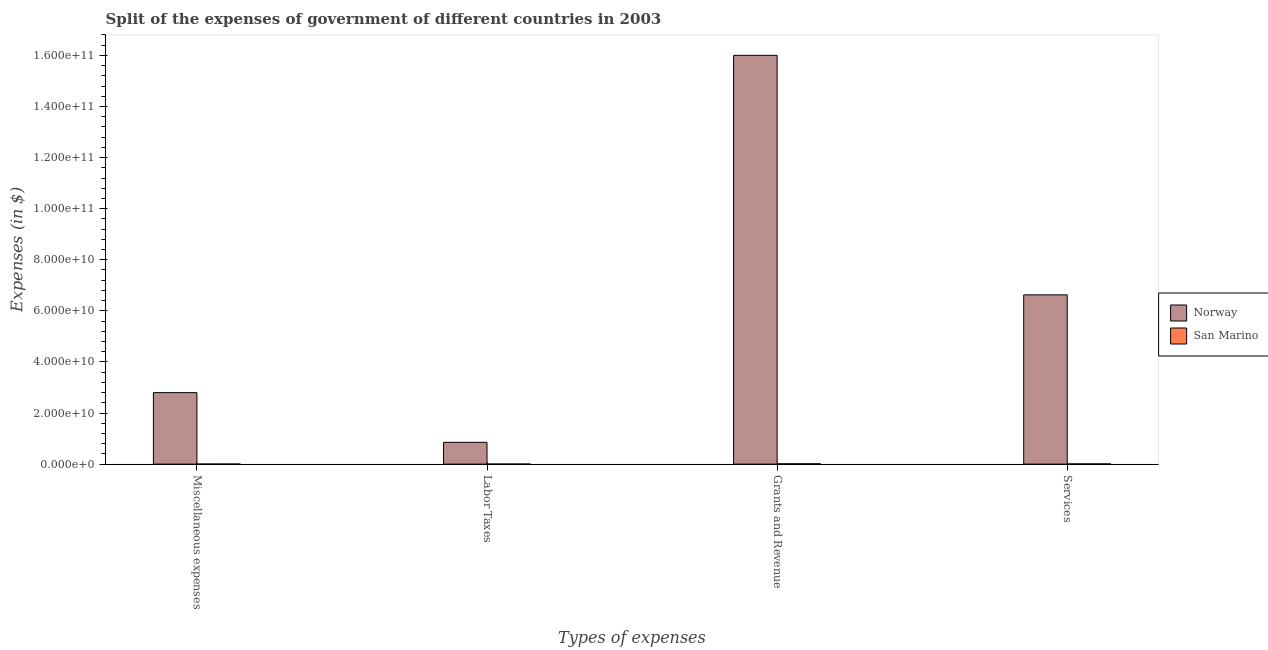How many groups of bars are there?
Offer a terse response. 4. Are the number of bars per tick equal to the number of legend labels?
Offer a terse response. Yes. Are the number of bars on each tick of the X-axis equal?
Keep it short and to the point. Yes. What is the label of the 2nd group of bars from the left?
Give a very brief answer. Labor Taxes. What is the amount spent on labor taxes in San Marino?
Keep it short and to the point. 1.21e+07. Across all countries, what is the maximum amount spent on labor taxes?
Make the answer very short. 8.53e+09. Across all countries, what is the minimum amount spent on miscellaneous expenses?
Ensure brevity in your answer.  2.96e+07. In which country was the amount spent on grants and revenue minimum?
Make the answer very short. San Marino. What is the total amount spent on services in the graph?
Your response must be concise. 6.63e+1. What is the difference between the amount spent on services in Norway and that in San Marino?
Provide a succinct answer. 6.62e+1. What is the difference between the amount spent on services in Norway and the amount spent on labor taxes in San Marino?
Make the answer very short. 6.63e+1. What is the average amount spent on miscellaneous expenses per country?
Your answer should be very brief. 1.40e+1. What is the difference between the amount spent on miscellaneous expenses and amount spent on grants and revenue in Norway?
Your answer should be compact. -1.32e+11. What is the ratio of the amount spent on grants and revenue in Norway to that in San Marino?
Ensure brevity in your answer.  1233.52. Is the amount spent on miscellaneous expenses in San Marino less than that in Norway?
Give a very brief answer. Yes. What is the difference between the highest and the second highest amount spent on labor taxes?
Provide a short and direct response. 8.52e+09. What is the difference between the highest and the lowest amount spent on grants and revenue?
Provide a succinct answer. 1.60e+11. What does the 2nd bar from the left in Miscellaneous expenses represents?
Give a very brief answer. San Marino. Is it the case that in every country, the sum of the amount spent on miscellaneous expenses and amount spent on labor taxes is greater than the amount spent on grants and revenue?
Your response must be concise. No. How many countries are there in the graph?
Keep it short and to the point. 2. Does the graph contain grids?
Your answer should be compact. No. How many legend labels are there?
Offer a very short reply. 2. How are the legend labels stacked?
Provide a short and direct response. Vertical. What is the title of the graph?
Give a very brief answer. Split of the expenses of government of different countries in 2003. Does "Libya" appear as one of the legend labels in the graph?
Your response must be concise. No. What is the label or title of the X-axis?
Make the answer very short. Types of expenses. What is the label or title of the Y-axis?
Offer a very short reply. Expenses (in $). What is the Expenses (in $) of Norway in Miscellaneous expenses?
Ensure brevity in your answer.  2.80e+1. What is the Expenses (in $) in San Marino in Miscellaneous expenses?
Provide a short and direct response. 2.96e+07. What is the Expenses (in $) in Norway in Labor Taxes?
Make the answer very short. 8.53e+09. What is the Expenses (in $) of San Marino in Labor Taxes?
Ensure brevity in your answer.  1.21e+07. What is the Expenses (in $) of Norway in Grants and Revenue?
Provide a short and direct response. 1.60e+11. What is the Expenses (in $) in San Marino in Grants and Revenue?
Ensure brevity in your answer.  1.30e+08. What is the Expenses (in $) of Norway in Services?
Offer a terse response. 6.63e+1. What is the Expenses (in $) of San Marino in Services?
Offer a very short reply. 8.06e+07. Across all Types of expenses, what is the maximum Expenses (in $) in Norway?
Your answer should be very brief. 1.60e+11. Across all Types of expenses, what is the maximum Expenses (in $) in San Marino?
Offer a very short reply. 1.30e+08. Across all Types of expenses, what is the minimum Expenses (in $) of Norway?
Offer a very short reply. 8.53e+09. Across all Types of expenses, what is the minimum Expenses (in $) in San Marino?
Make the answer very short. 1.21e+07. What is the total Expenses (in $) of Norway in the graph?
Your answer should be compact. 2.63e+11. What is the total Expenses (in $) of San Marino in the graph?
Keep it short and to the point. 2.52e+08. What is the difference between the Expenses (in $) of Norway in Miscellaneous expenses and that in Labor Taxes?
Ensure brevity in your answer.  1.94e+1. What is the difference between the Expenses (in $) in San Marino in Miscellaneous expenses and that in Labor Taxes?
Ensure brevity in your answer.  1.75e+07. What is the difference between the Expenses (in $) in Norway in Miscellaneous expenses and that in Grants and Revenue?
Give a very brief answer. -1.32e+11. What is the difference between the Expenses (in $) in San Marino in Miscellaneous expenses and that in Grants and Revenue?
Provide a succinct answer. -1.00e+08. What is the difference between the Expenses (in $) of Norway in Miscellaneous expenses and that in Services?
Your response must be concise. -3.83e+1. What is the difference between the Expenses (in $) in San Marino in Miscellaneous expenses and that in Services?
Provide a short and direct response. -5.10e+07. What is the difference between the Expenses (in $) in Norway in Labor Taxes and that in Grants and Revenue?
Your response must be concise. -1.51e+11. What is the difference between the Expenses (in $) of San Marino in Labor Taxes and that in Grants and Revenue?
Your answer should be compact. -1.18e+08. What is the difference between the Expenses (in $) in Norway in Labor Taxes and that in Services?
Make the answer very short. -5.77e+1. What is the difference between the Expenses (in $) of San Marino in Labor Taxes and that in Services?
Provide a succinct answer. -6.85e+07. What is the difference between the Expenses (in $) in Norway in Grants and Revenue and that in Services?
Keep it short and to the point. 9.38e+1. What is the difference between the Expenses (in $) of San Marino in Grants and Revenue and that in Services?
Your answer should be very brief. 4.91e+07. What is the difference between the Expenses (in $) in Norway in Miscellaneous expenses and the Expenses (in $) in San Marino in Labor Taxes?
Provide a short and direct response. 2.80e+1. What is the difference between the Expenses (in $) in Norway in Miscellaneous expenses and the Expenses (in $) in San Marino in Grants and Revenue?
Keep it short and to the point. 2.79e+1. What is the difference between the Expenses (in $) of Norway in Miscellaneous expenses and the Expenses (in $) of San Marino in Services?
Make the answer very short. 2.79e+1. What is the difference between the Expenses (in $) of Norway in Labor Taxes and the Expenses (in $) of San Marino in Grants and Revenue?
Provide a short and direct response. 8.40e+09. What is the difference between the Expenses (in $) of Norway in Labor Taxes and the Expenses (in $) of San Marino in Services?
Give a very brief answer. 8.45e+09. What is the difference between the Expenses (in $) of Norway in Grants and Revenue and the Expenses (in $) of San Marino in Services?
Ensure brevity in your answer.  1.60e+11. What is the average Expenses (in $) in Norway per Types of expenses?
Keep it short and to the point. 6.57e+1. What is the average Expenses (in $) of San Marino per Types of expenses?
Offer a terse response. 6.30e+07. What is the difference between the Expenses (in $) of Norway and Expenses (in $) of San Marino in Miscellaneous expenses?
Your answer should be compact. 2.80e+1. What is the difference between the Expenses (in $) of Norway and Expenses (in $) of San Marino in Labor Taxes?
Your answer should be very brief. 8.52e+09. What is the difference between the Expenses (in $) of Norway and Expenses (in $) of San Marino in Grants and Revenue?
Keep it short and to the point. 1.60e+11. What is the difference between the Expenses (in $) of Norway and Expenses (in $) of San Marino in Services?
Offer a terse response. 6.62e+1. What is the ratio of the Expenses (in $) of Norway in Miscellaneous expenses to that in Labor Taxes?
Provide a succinct answer. 3.28. What is the ratio of the Expenses (in $) of San Marino in Miscellaneous expenses to that in Labor Taxes?
Provide a succinct answer. 2.45. What is the ratio of the Expenses (in $) of Norway in Miscellaneous expenses to that in Grants and Revenue?
Provide a short and direct response. 0.17. What is the ratio of the Expenses (in $) of San Marino in Miscellaneous expenses to that in Grants and Revenue?
Your answer should be compact. 0.23. What is the ratio of the Expenses (in $) in Norway in Miscellaneous expenses to that in Services?
Provide a succinct answer. 0.42. What is the ratio of the Expenses (in $) in San Marino in Miscellaneous expenses to that in Services?
Give a very brief answer. 0.37. What is the ratio of the Expenses (in $) in Norway in Labor Taxes to that in Grants and Revenue?
Your response must be concise. 0.05. What is the ratio of the Expenses (in $) in San Marino in Labor Taxes to that in Grants and Revenue?
Give a very brief answer. 0.09. What is the ratio of the Expenses (in $) of Norway in Labor Taxes to that in Services?
Offer a terse response. 0.13. What is the ratio of the Expenses (in $) in San Marino in Labor Taxes to that in Services?
Offer a terse response. 0.15. What is the ratio of the Expenses (in $) in Norway in Grants and Revenue to that in Services?
Offer a terse response. 2.41. What is the ratio of the Expenses (in $) in San Marino in Grants and Revenue to that in Services?
Provide a short and direct response. 1.61. What is the difference between the highest and the second highest Expenses (in $) of Norway?
Keep it short and to the point. 9.38e+1. What is the difference between the highest and the second highest Expenses (in $) of San Marino?
Your answer should be compact. 4.91e+07. What is the difference between the highest and the lowest Expenses (in $) in Norway?
Provide a short and direct response. 1.51e+11. What is the difference between the highest and the lowest Expenses (in $) in San Marino?
Offer a very short reply. 1.18e+08. 